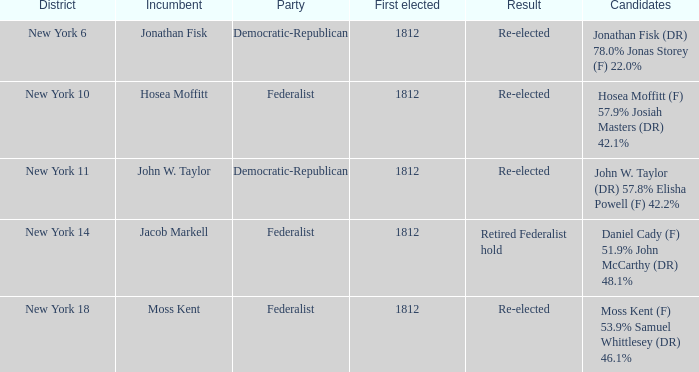Name the most first elected 1812.0. 